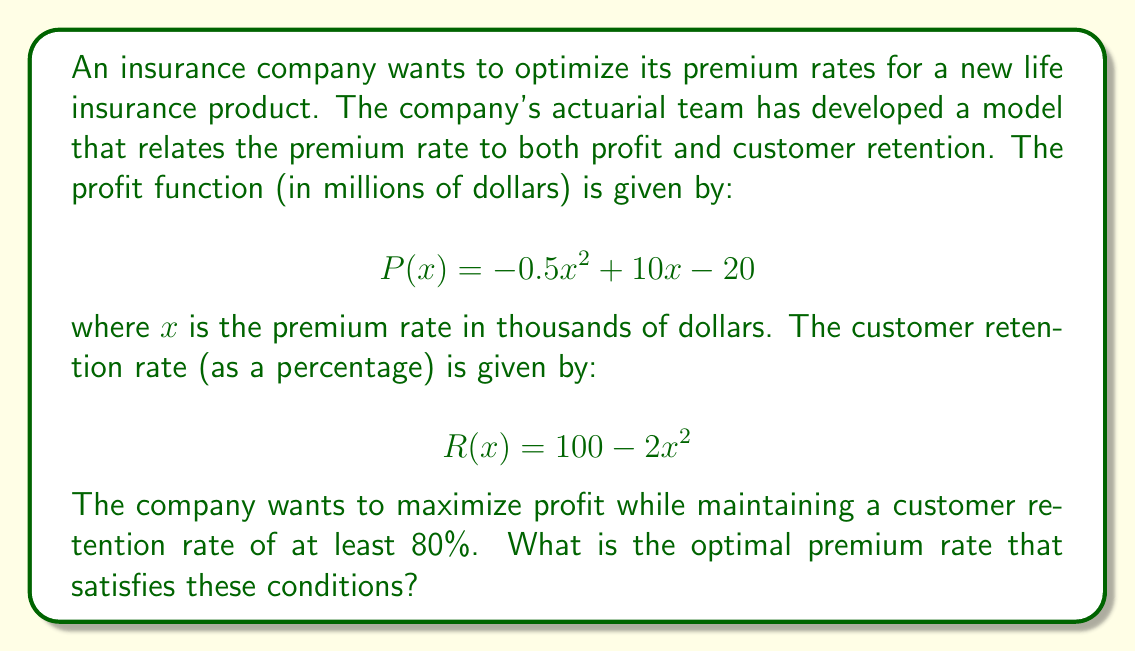Solve this math problem. To solve this optimization problem, we need to follow these steps:

1) First, we need to determine the constraint on $x$ based on the retention rate:
   
   $R(x) = 100 - 2x^2 \geq 80$
   $-2x^2 \geq -20$
   $x^2 \leq 10$
   $x \leq \sqrt{10} \approx 3.16$

2) Now, we need to find the maximum of the profit function $P(x)$ within this constraint.

3) To find the maximum of $P(x)$, we differentiate and set it to zero:
   
   $P'(x) = -x + 10$
   $-x + 10 = 0$
   $x = 10$

4) However, $x = 10$ is outside our constraint of $x \leq \sqrt{10}$.

5) Since the profit function is a downward-facing parabola (coefficient of $x^2$ is negative), and the maximum point is to the right of our constraint, the maximum within our constraint will occur at the boundary of the constraint.

6) Therefore, the optimal premium rate is $x = \sqrt{10}$.

7) We can verify that this satisfies the retention rate condition:
   
   $R(\sqrt{10}) = 100 - 2(\sqrt{10})^2 = 100 - 20 = 80$

8) The corresponding profit is:
   
   $P(\sqrt{10}) = -0.5(\sqrt{10})^2 + 10\sqrt{10} - 20$
                 $= -5 + 10\sqrt{10} - 20$
                 $= 10\sqrt{10} - 25$
                 $\approx 6.62$ million dollars
Answer: The optimal premium rate is $\sqrt{10} \approx 3.16$ thousand dollars, which yields a profit of $10\sqrt{10} - 25 \approx 6.62$ million dollars and maintains a customer retention rate of exactly 80%. 